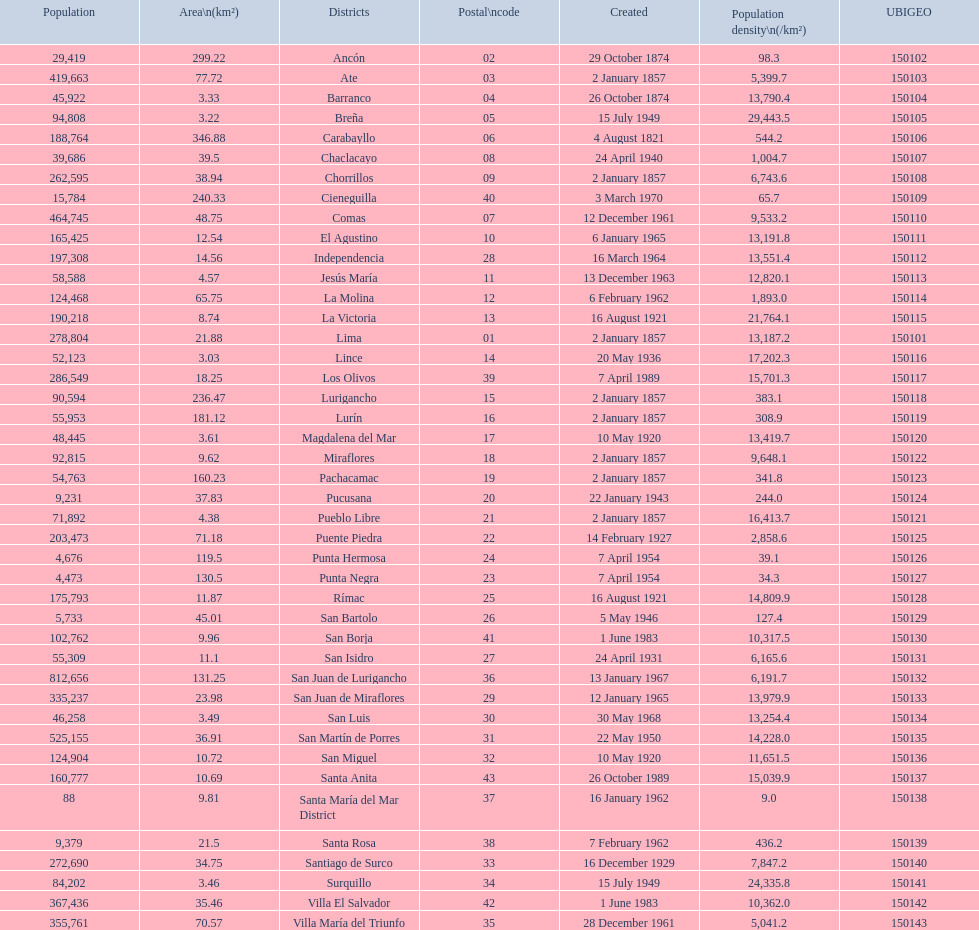How many districts within this city are home to more than 100,000 residents? 21. 